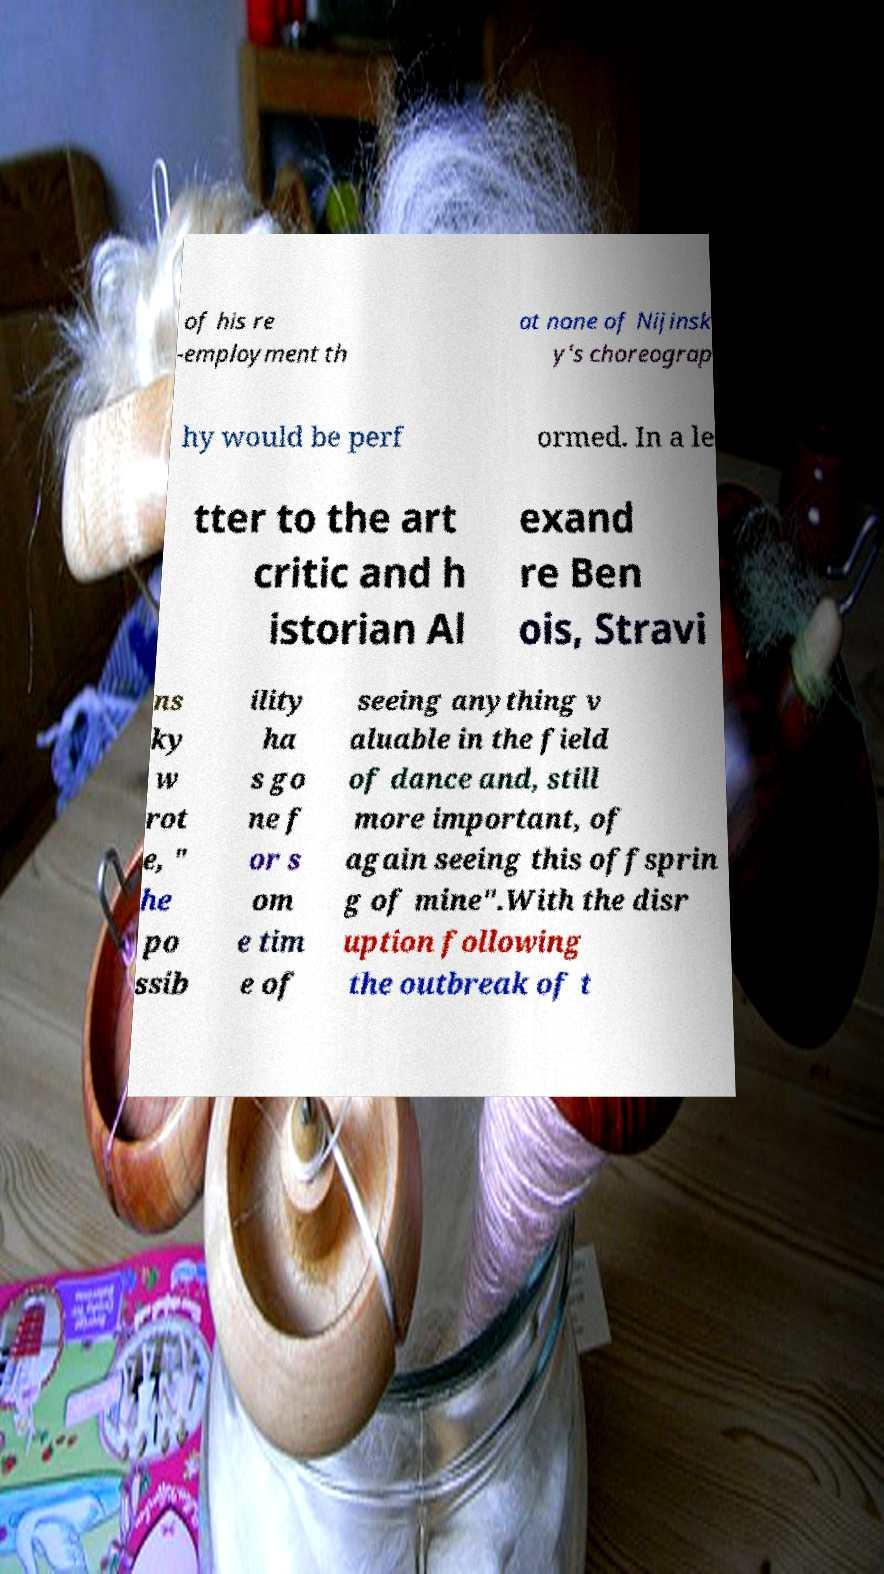Please identify and transcribe the text found in this image. of his re -employment th at none of Nijinsk y's choreograp hy would be perf ormed. In a le tter to the art critic and h istorian Al exand re Ben ois, Stravi ns ky w rot e, " he po ssib ility ha s go ne f or s om e tim e of seeing anything v aluable in the field of dance and, still more important, of again seeing this offsprin g of mine".With the disr uption following the outbreak of t 